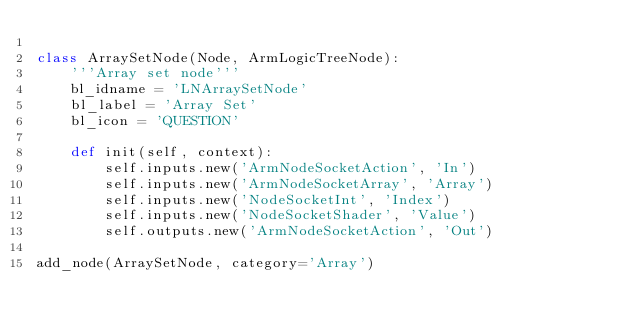Convert code to text. <code><loc_0><loc_0><loc_500><loc_500><_Python_>
class ArraySetNode(Node, ArmLogicTreeNode):
    '''Array set node'''
    bl_idname = 'LNArraySetNode'
    bl_label = 'Array Set'
    bl_icon = 'QUESTION'

    def init(self, context):
        self.inputs.new('ArmNodeSocketAction', 'In')
        self.inputs.new('ArmNodeSocketArray', 'Array')
        self.inputs.new('NodeSocketInt', 'Index')
        self.inputs.new('NodeSocketShader', 'Value')
        self.outputs.new('ArmNodeSocketAction', 'Out')

add_node(ArraySetNode, category='Array')
</code> 